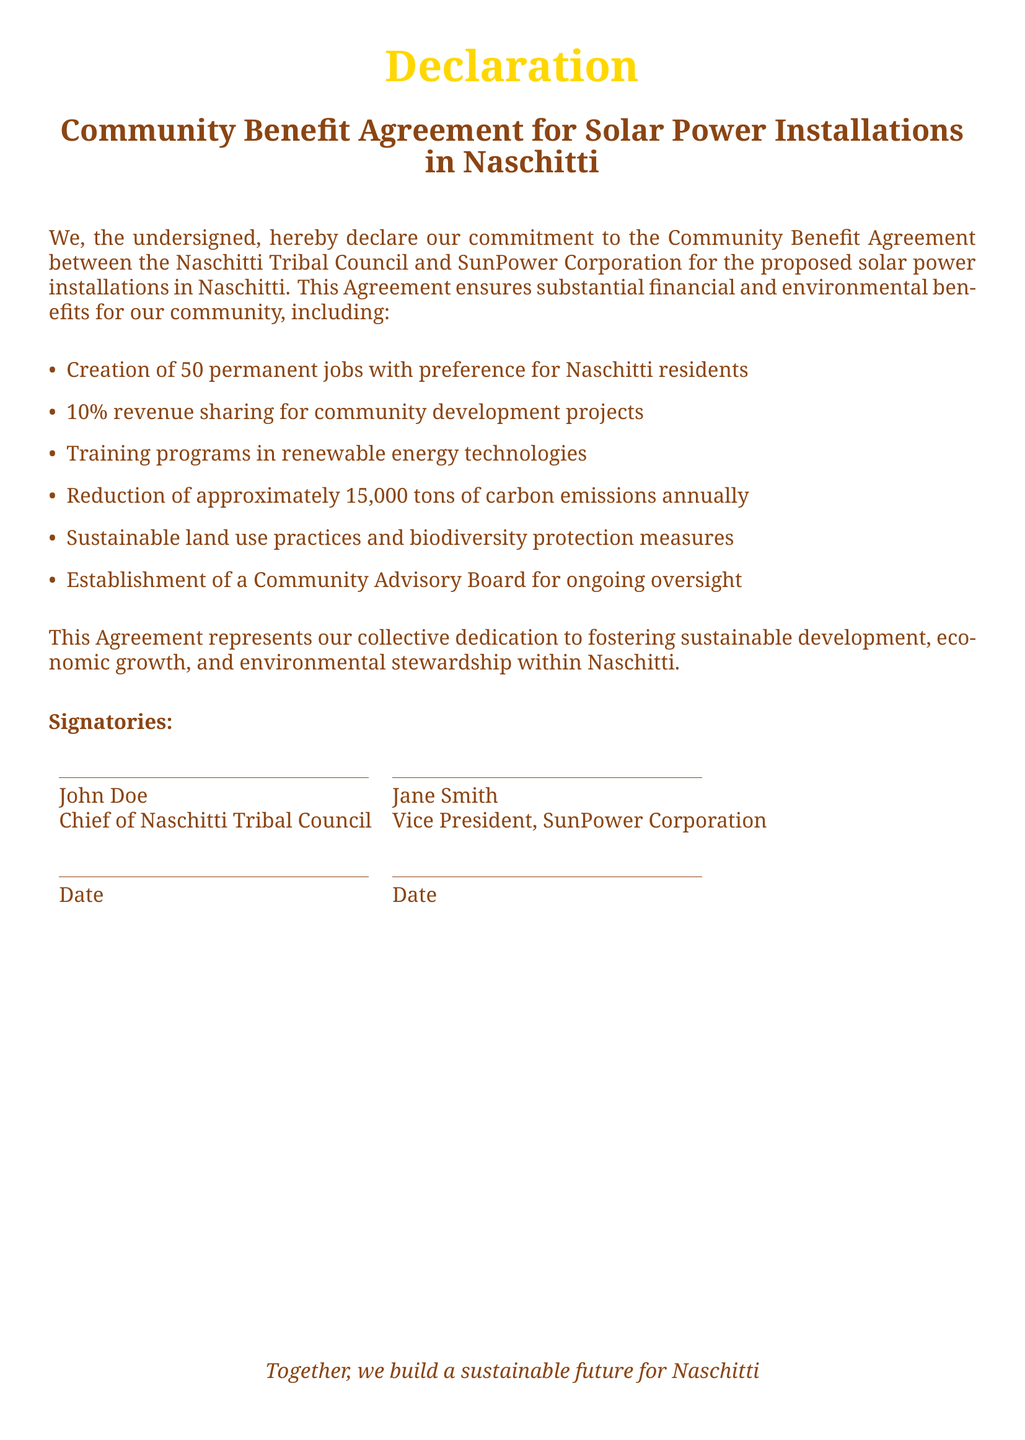What is the title of the document? The title of the document is provided at the top center, indicating the subject matter of the declaration.
Answer: Community Benefit Agreement for Solar Power Installations in Naschitti Who are the signatories? The signatories are listed at the bottom of the document, identifying the individuals involved in the agreement.
Answer: John Doe and Jane Smith How many permanent jobs will be created? The document specifies the number of jobs directly in the list of benefits from the agreement.
Answer: 50 What percentage of revenue will be shared for community development? The document states the percentage of shared revenue as part of the benefits outlined in the agreement.
Answer: 10% How much carbon emissions will be reduced annually? The document provides a specific figure regarding the expected reduction in carbon emissions over the year.
Answer: 15,000 tons What is the purpose of the Community Advisory Board? This is found in the list of benefits, indicating the intent of establishing a board for oversight.
Answer: Ongoing oversight What is the overarching goal of this agreement? The document includes a statement about the aim of fostering certain outcomes for the community.
Answer: Sustainable development, economic growth, and environmental stewardship 